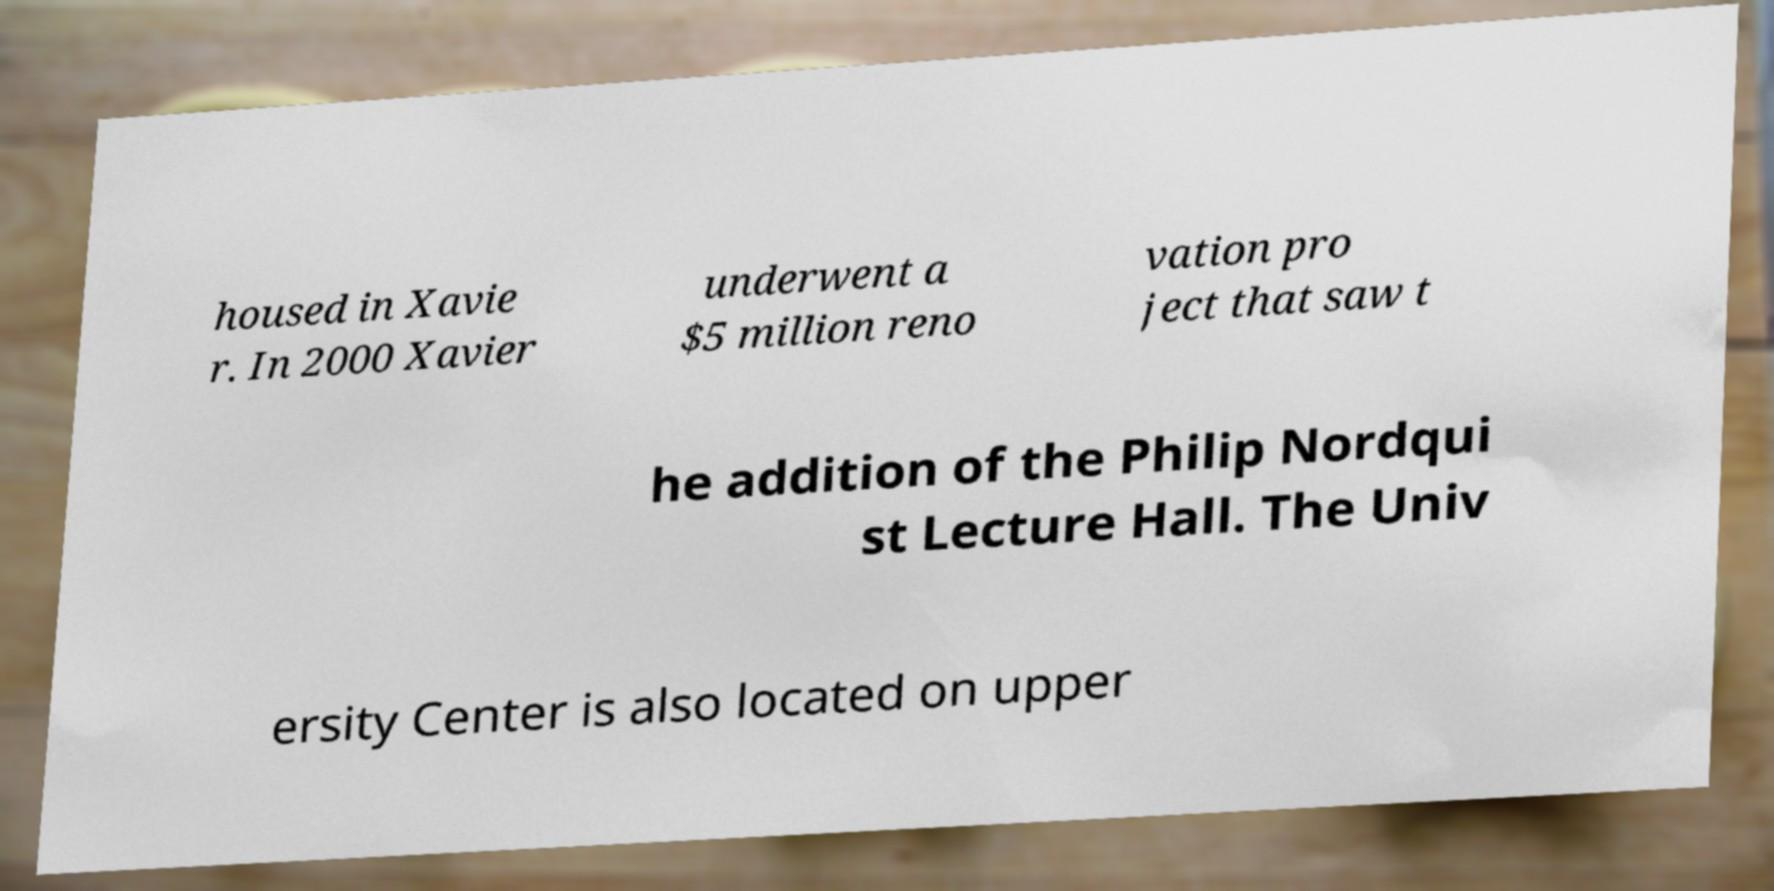For documentation purposes, I need the text within this image transcribed. Could you provide that? housed in Xavie r. In 2000 Xavier underwent a $5 million reno vation pro ject that saw t he addition of the Philip Nordqui st Lecture Hall. The Univ ersity Center is also located on upper 